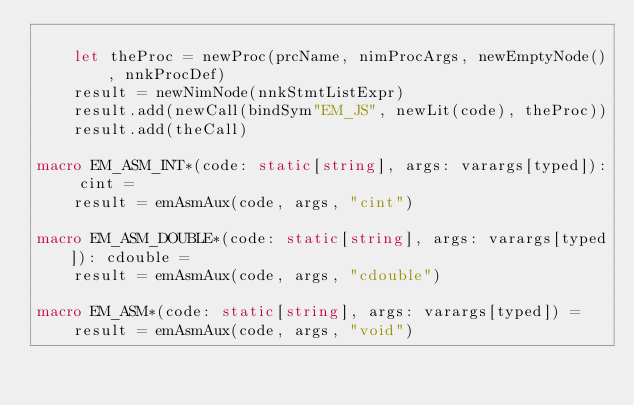<code> <loc_0><loc_0><loc_500><loc_500><_Nim_>
    let theProc = newProc(prcName, nimProcArgs, newEmptyNode(), nnkProcDef)
    result = newNimNode(nnkStmtListExpr)
    result.add(newCall(bindSym"EM_JS", newLit(code), theProc))
    result.add(theCall)

macro EM_ASM_INT*(code: static[string], args: varargs[typed]): cint =
    result = emAsmAux(code, args, "cint")

macro EM_ASM_DOUBLE*(code: static[string], args: varargs[typed]): cdouble =
    result = emAsmAux(code, args, "cdouble")

macro EM_ASM*(code: static[string], args: varargs[typed]) =
    result = emAsmAux(code, args, "void")
</code> 